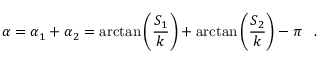Convert formula to latex. <formula><loc_0><loc_0><loc_500><loc_500>\alpha = \alpha _ { 1 } + \alpha _ { 2 } = \arctan \left ( \frac { S _ { 1 } } k \right ) + \arctan \left ( \frac { S _ { 2 } } k \right ) - \pi \, \ \ .</formula> 